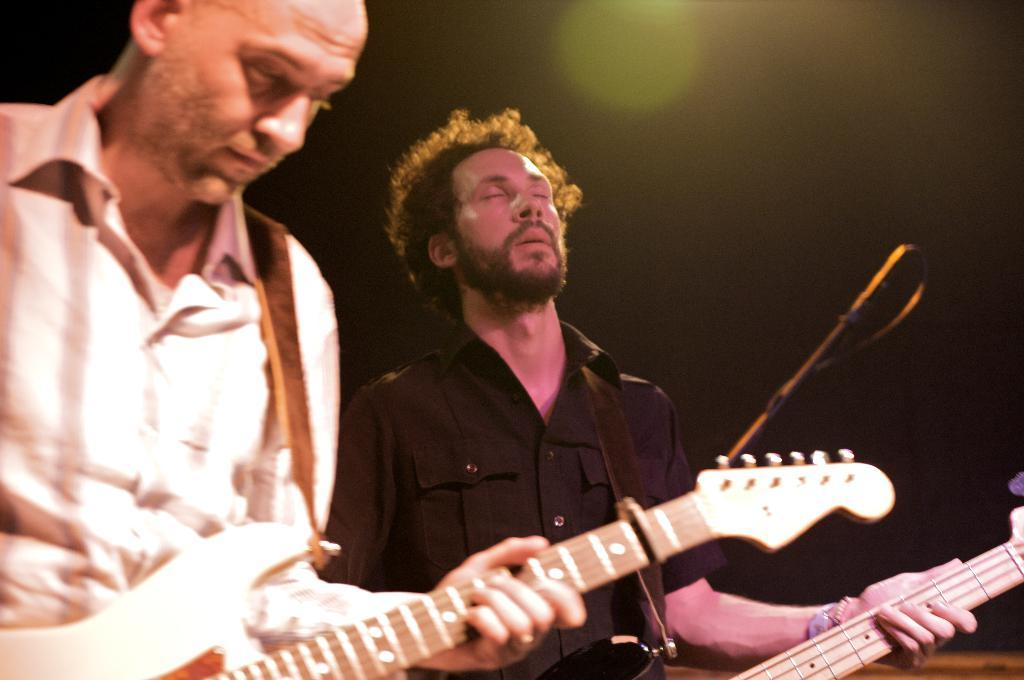How many people are in the image? There are two persons in the image. What are the two persons doing in the image? Both persons are playing guitars. What type of company is depicted in the image? There is no company depicted in the image; it features two persons playing guitars. What brand of jeans is the person on the left wearing in the image? There is no information about the brand of jeans or any clothing in the image. 